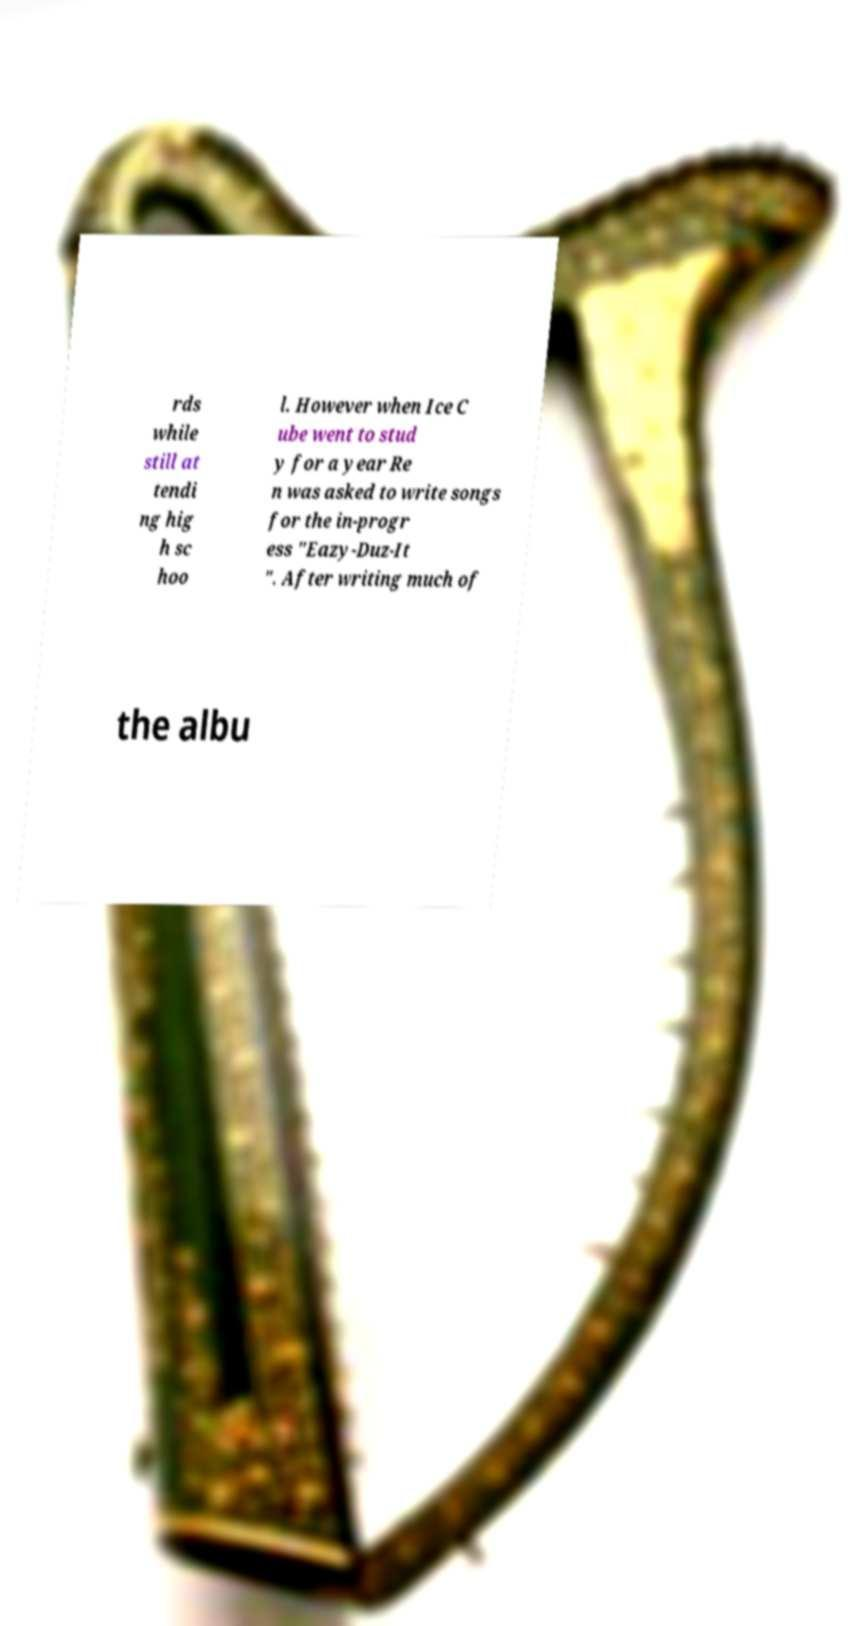Could you extract and type out the text from this image? rds while still at tendi ng hig h sc hoo l. However when Ice C ube went to stud y for a year Re n was asked to write songs for the in-progr ess "Eazy-Duz-It ". After writing much of the albu 